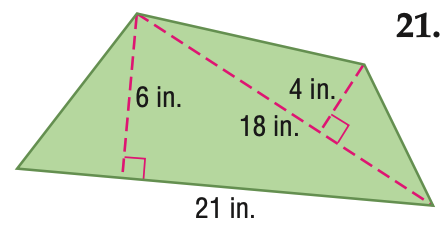Question: Find the area of the figure. Round to the nearest tenth if necessary.
Choices:
A. 72
B. 99
C. 126
D. 198
Answer with the letter. Answer: B 